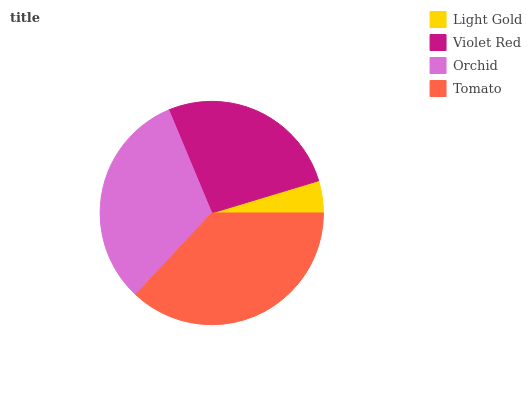Is Light Gold the minimum?
Answer yes or no. Yes. Is Tomato the maximum?
Answer yes or no. Yes. Is Violet Red the minimum?
Answer yes or no. No. Is Violet Red the maximum?
Answer yes or no. No. Is Violet Red greater than Light Gold?
Answer yes or no. Yes. Is Light Gold less than Violet Red?
Answer yes or no. Yes. Is Light Gold greater than Violet Red?
Answer yes or no. No. Is Violet Red less than Light Gold?
Answer yes or no. No. Is Orchid the high median?
Answer yes or no. Yes. Is Violet Red the low median?
Answer yes or no. Yes. Is Violet Red the high median?
Answer yes or no. No. Is Orchid the low median?
Answer yes or no. No. 